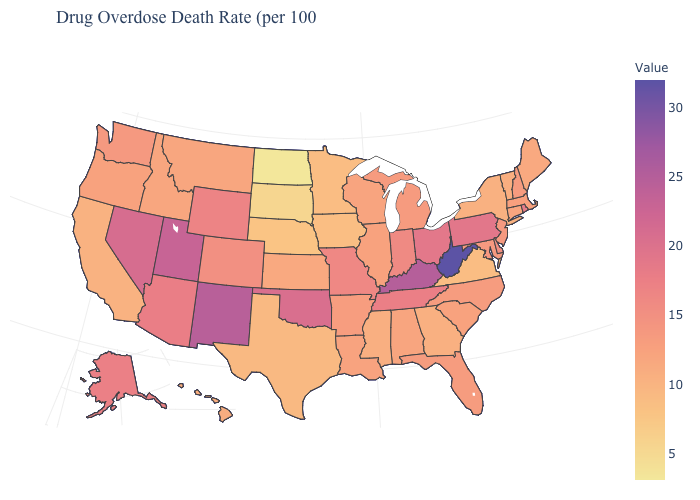Does Texas have a higher value than North Dakota?
Be succinct. Yes. Among the states that border Texas , does New Mexico have the highest value?
Quick response, please. Yes. Among the states that border South Dakota , does North Dakota have the lowest value?
Concise answer only. Yes. Among the states that border North Carolina , does Tennessee have the lowest value?
Quick response, please. No. Is the legend a continuous bar?
Write a very short answer. Yes. 